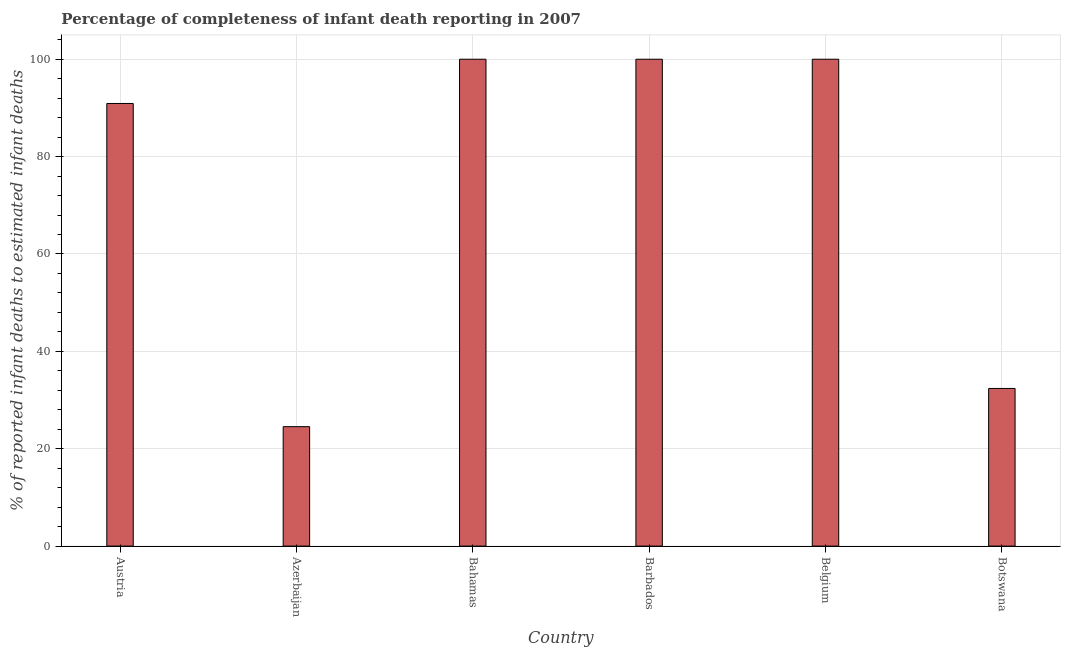Does the graph contain any zero values?
Provide a succinct answer. No. Does the graph contain grids?
Your answer should be very brief. Yes. What is the title of the graph?
Ensure brevity in your answer.  Percentage of completeness of infant death reporting in 2007. What is the label or title of the X-axis?
Offer a very short reply. Country. What is the label or title of the Y-axis?
Your response must be concise. % of reported infant deaths to estimated infant deaths. What is the completeness of infant death reporting in Azerbaijan?
Give a very brief answer. 24.53. Across all countries, what is the minimum completeness of infant death reporting?
Ensure brevity in your answer.  24.53. In which country was the completeness of infant death reporting maximum?
Make the answer very short. Bahamas. In which country was the completeness of infant death reporting minimum?
Make the answer very short. Azerbaijan. What is the sum of the completeness of infant death reporting?
Ensure brevity in your answer.  447.82. What is the difference between the completeness of infant death reporting in Austria and Bahamas?
Offer a terse response. -9.09. What is the average completeness of infant death reporting per country?
Your answer should be compact. 74.64. What is the median completeness of infant death reporting?
Provide a succinct answer. 95.45. In how many countries, is the completeness of infant death reporting greater than 80 %?
Your answer should be very brief. 4. What is the ratio of the completeness of infant death reporting in Azerbaijan to that in Barbados?
Give a very brief answer. 0.24. Is the difference between the completeness of infant death reporting in Belgium and Botswana greater than the difference between any two countries?
Your answer should be very brief. No. Is the sum of the completeness of infant death reporting in Austria and Belgium greater than the maximum completeness of infant death reporting across all countries?
Provide a succinct answer. Yes. What is the difference between the highest and the lowest completeness of infant death reporting?
Give a very brief answer. 75.47. In how many countries, is the completeness of infant death reporting greater than the average completeness of infant death reporting taken over all countries?
Provide a succinct answer. 4. How many bars are there?
Provide a succinct answer. 6. Are the values on the major ticks of Y-axis written in scientific E-notation?
Ensure brevity in your answer.  No. What is the % of reported infant deaths to estimated infant deaths in Austria?
Your answer should be compact. 90.91. What is the % of reported infant deaths to estimated infant deaths in Azerbaijan?
Offer a very short reply. 24.53. What is the % of reported infant deaths to estimated infant deaths in Botswana?
Offer a very short reply. 32.38. What is the difference between the % of reported infant deaths to estimated infant deaths in Austria and Azerbaijan?
Keep it short and to the point. 66.38. What is the difference between the % of reported infant deaths to estimated infant deaths in Austria and Bahamas?
Offer a very short reply. -9.09. What is the difference between the % of reported infant deaths to estimated infant deaths in Austria and Barbados?
Make the answer very short. -9.09. What is the difference between the % of reported infant deaths to estimated infant deaths in Austria and Belgium?
Give a very brief answer. -9.09. What is the difference between the % of reported infant deaths to estimated infant deaths in Austria and Botswana?
Your response must be concise. 58.53. What is the difference between the % of reported infant deaths to estimated infant deaths in Azerbaijan and Bahamas?
Offer a terse response. -75.47. What is the difference between the % of reported infant deaths to estimated infant deaths in Azerbaijan and Barbados?
Your answer should be very brief. -75.47. What is the difference between the % of reported infant deaths to estimated infant deaths in Azerbaijan and Belgium?
Your answer should be very brief. -75.47. What is the difference between the % of reported infant deaths to estimated infant deaths in Azerbaijan and Botswana?
Give a very brief answer. -7.85. What is the difference between the % of reported infant deaths to estimated infant deaths in Bahamas and Barbados?
Offer a terse response. 0. What is the difference between the % of reported infant deaths to estimated infant deaths in Bahamas and Belgium?
Offer a very short reply. 0. What is the difference between the % of reported infant deaths to estimated infant deaths in Bahamas and Botswana?
Your answer should be very brief. 67.62. What is the difference between the % of reported infant deaths to estimated infant deaths in Barbados and Botswana?
Your answer should be compact. 67.62. What is the difference between the % of reported infant deaths to estimated infant deaths in Belgium and Botswana?
Provide a succinct answer. 67.62. What is the ratio of the % of reported infant deaths to estimated infant deaths in Austria to that in Azerbaijan?
Make the answer very short. 3.71. What is the ratio of the % of reported infant deaths to estimated infant deaths in Austria to that in Bahamas?
Provide a short and direct response. 0.91. What is the ratio of the % of reported infant deaths to estimated infant deaths in Austria to that in Barbados?
Ensure brevity in your answer.  0.91. What is the ratio of the % of reported infant deaths to estimated infant deaths in Austria to that in Belgium?
Your answer should be very brief. 0.91. What is the ratio of the % of reported infant deaths to estimated infant deaths in Austria to that in Botswana?
Your answer should be compact. 2.81. What is the ratio of the % of reported infant deaths to estimated infant deaths in Azerbaijan to that in Bahamas?
Provide a succinct answer. 0.24. What is the ratio of the % of reported infant deaths to estimated infant deaths in Azerbaijan to that in Barbados?
Keep it short and to the point. 0.24. What is the ratio of the % of reported infant deaths to estimated infant deaths in Azerbaijan to that in Belgium?
Make the answer very short. 0.24. What is the ratio of the % of reported infant deaths to estimated infant deaths in Azerbaijan to that in Botswana?
Give a very brief answer. 0.76. What is the ratio of the % of reported infant deaths to estimated infant deaths in Bahamas to that in Botswana?
Offer a very short reply. 3.09. What is the ratio of the % of reported infant deaths to estimated infant deaths in Barbados to that in Botswana?
Your answer should be compact. 3.09. What is the ratio of the % of reported infant deaths to estimated infant deaths in Belgium to that in Botswana?
Make the answer very short. 3.09. 